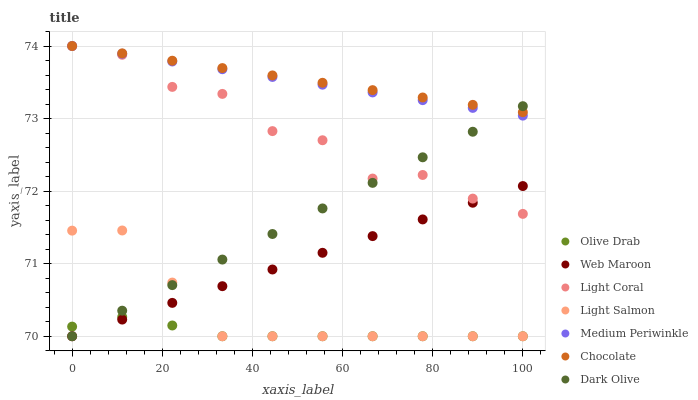Does Olive Drab have the minimum area under the curve?
Answer yes or no. Yes. Does Chocolate have the maximum area under the curve?
Answer yes or no. Yes. Does Web Maroon have the minimum area under the curve?
Answer yes or no. No. Does Web Maroon have the maximum area under the curve?
Answer yes or no. No. Is Medium Periwinkle the smoothest?
Answer yes or no. Yes. Is Light Coral the roughest?
Answer yes or no. Yes. Is Web Maroon the smoothest?
Answer yes or no. No. Is Web Maroon the roughest?
Answer yes or no. No. Does Light Salmon have the lowest value?
Answer yes or no. Yes. Does Medium Periwinkle have the lowest value?
Answer yes or no. No. Does Light Coral have the highest value?
Answer yes or no. Yes. Does Web Maroon have the highest value?
Answer yes or no. No. Is Olive Drab less than Chocolate?
Answer yes or no. Yes. Is Light Coral greater than Olive Drab?
Answer yes or no. Yes. Does Olive Drab intersect Dark Olive?
Answer yes or no. Yes. Is Olive Drab less than Dark Olive?
Answer yes or no. No. Is Olive Drab greater than Dark Olive?
Answer yes or no. No. Does Olive Drab intersect Chocolate?
Answer yes or no. No. 